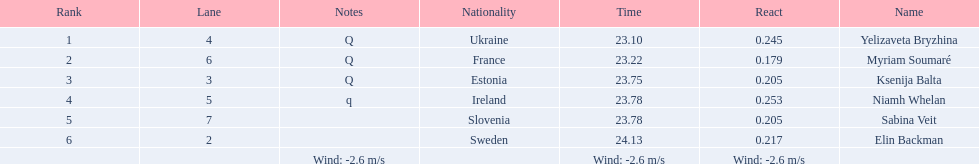The difference between yelizaveta bryzhina's time and ksenija balta's time? 0.65. 